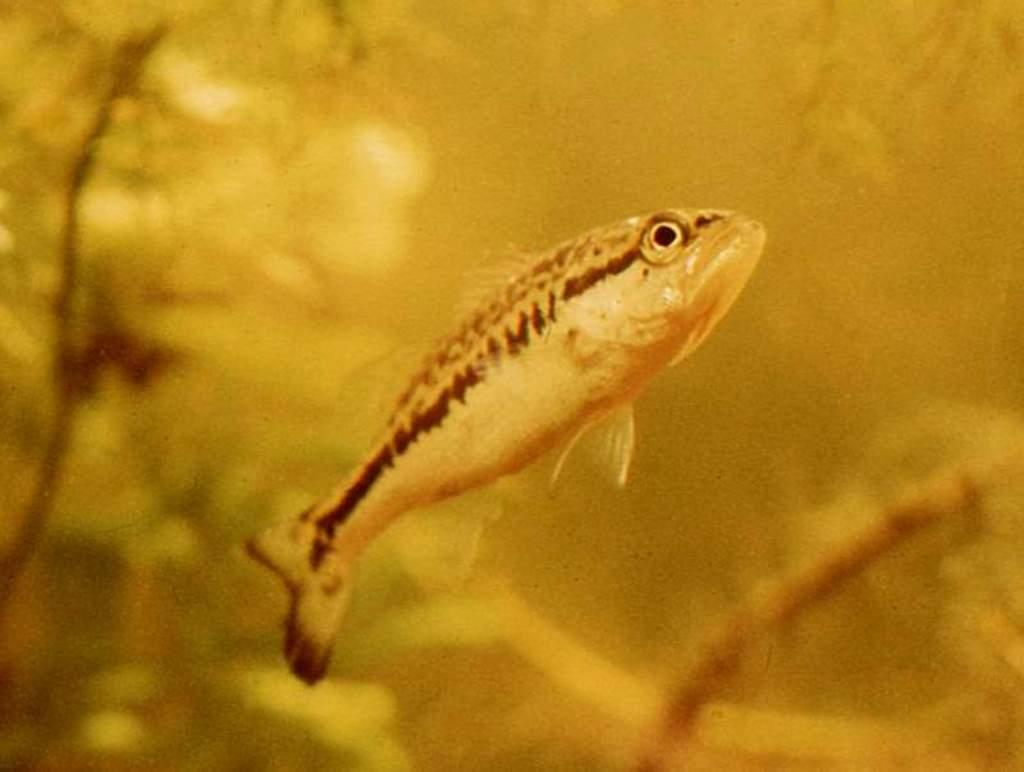What color is the background of the image? The background of the image is yellow. What is the main subject of the image? There is a fish present at the center of the image. How many toads are present in the image? There are no toads present in the image; it features a fish in a yellow background. 